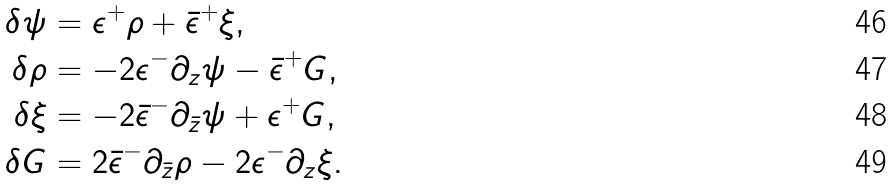<formula> <loc_0><loc_0><loc_500><loc_500>\delta \psi & = \epsilon ^ { + } \rho + \bar { \epsilon } ^ { + } \xi , \\ \delta \rho & = - 2 \epsilon ^ { - } \partial _ { z } \psi - \bar { \epsilon } ^ { + } G , \\ \delta \xi & = - 2 \bar { \epsilon } ^ { - } \partial _ { \bar { z } } \psi + \epsilon ^ { + } G , \\ \delta G & = 2 \bar { \epsilon } ^ { - } \partial _ { \bar { z } } \rho - 2 \epsilon ^ { - } \partial _ { z } \xi .</formula> 